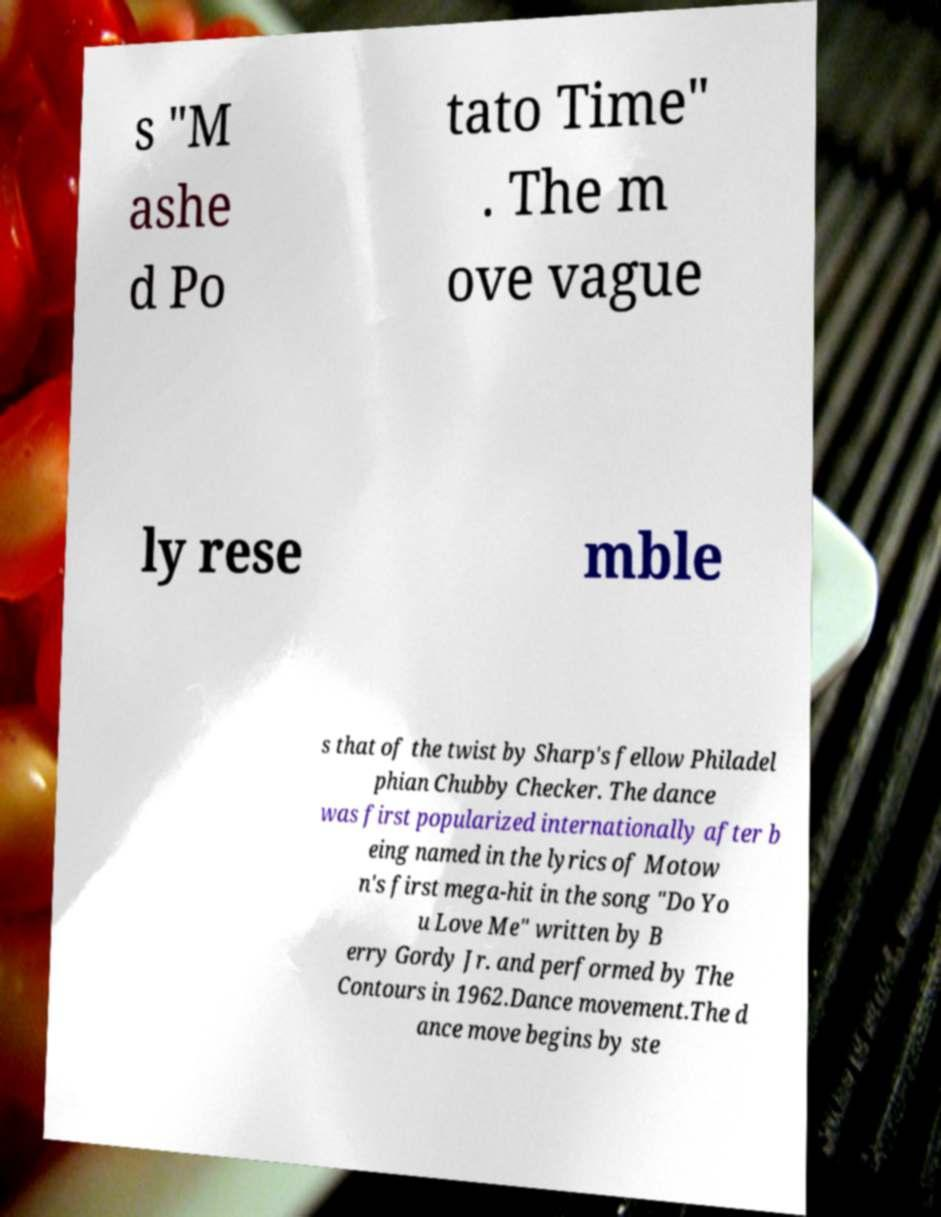Please read and relay the text visible in this image. What does it say? s "M ashe d Po tato Time" . The m ove vague ly rese mble s that of the twist by Sharp's fellow Philadel phian Chubby Checker. The dance was first popularized internationally after b eing named in the lyrics of Motow n's first mega-hit in the song "Do Yo u Love Me" written by B erry Gordy Jr. and performed by The Contours in 1962.Dance movement.The d ance move begins by ste 